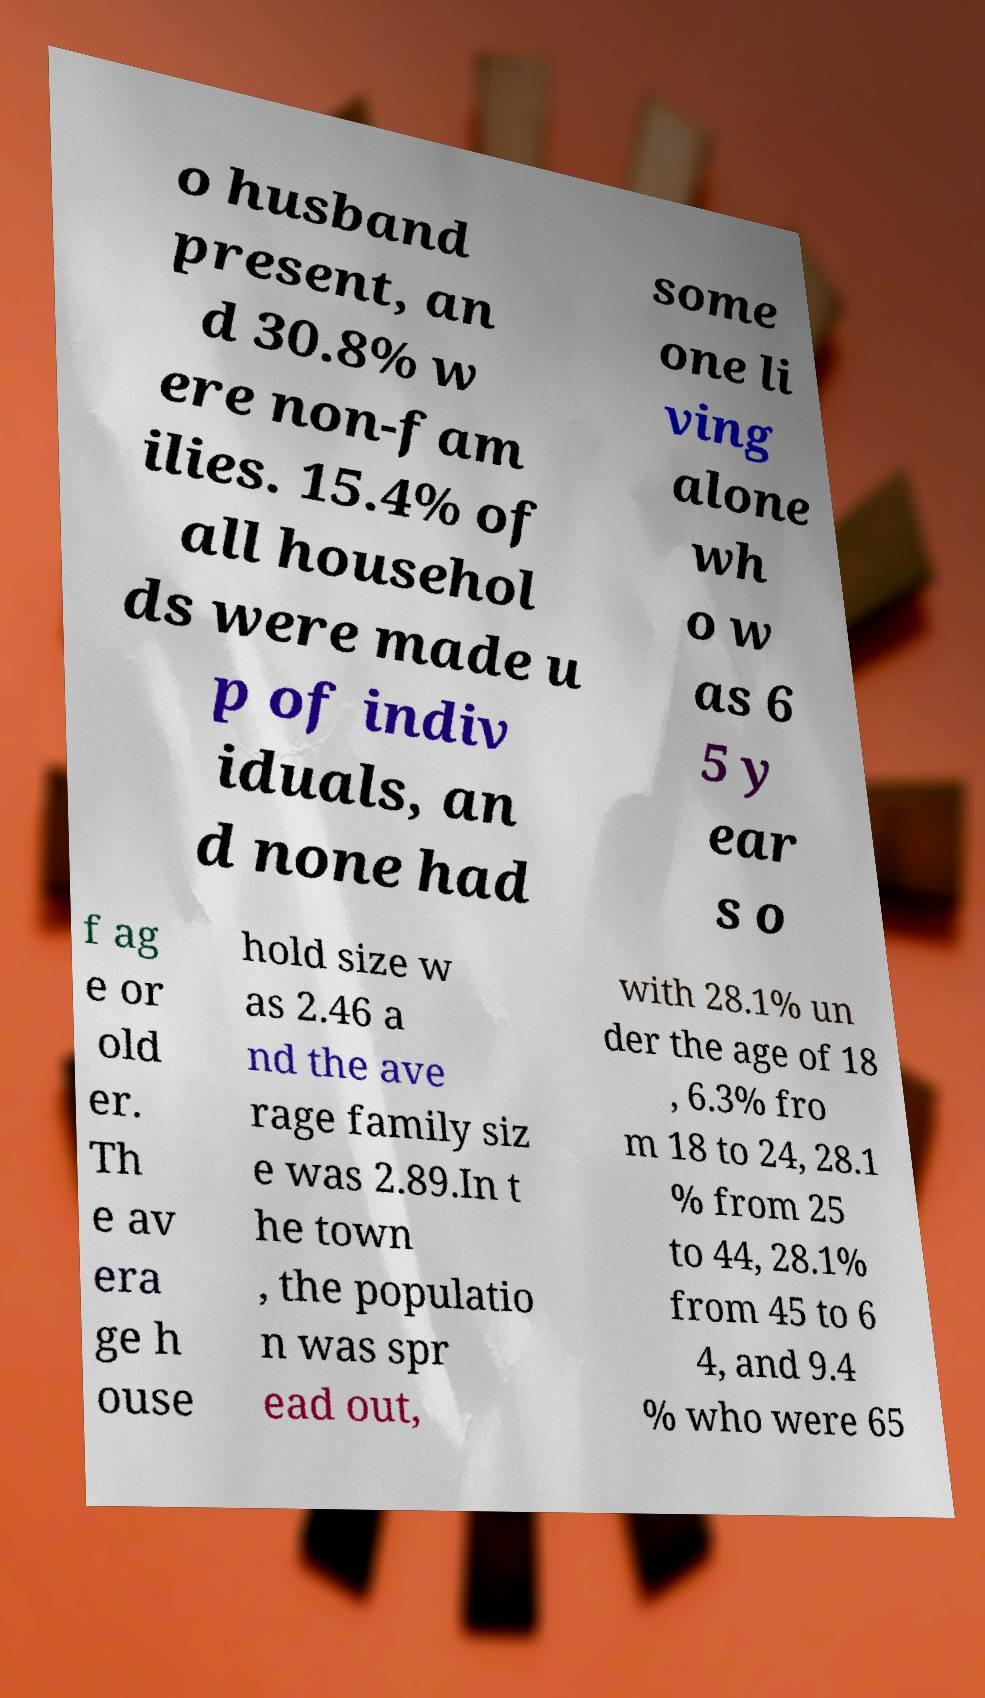Please identify and transcribe the text found in this image. o husband present, an d 30.8% w ere non-fam ilies. 15.4% of all househol ds were made u p of indiv iduals, an d none had some one li ving alone wh o w as 6 5 y ear s o f ag e or old er. Th e av era ge h ouse hold size w as 2.46 a nd the ave rage family siz e was 2.89.In t he town , the populatio n was spr ead out, with 28.1% un der the age of 18 , 6.3% fro m 18 to 24, 28.1 % from 25 to 44, 28.1% from 45 to 6 4, and 9.4 % who were 65 